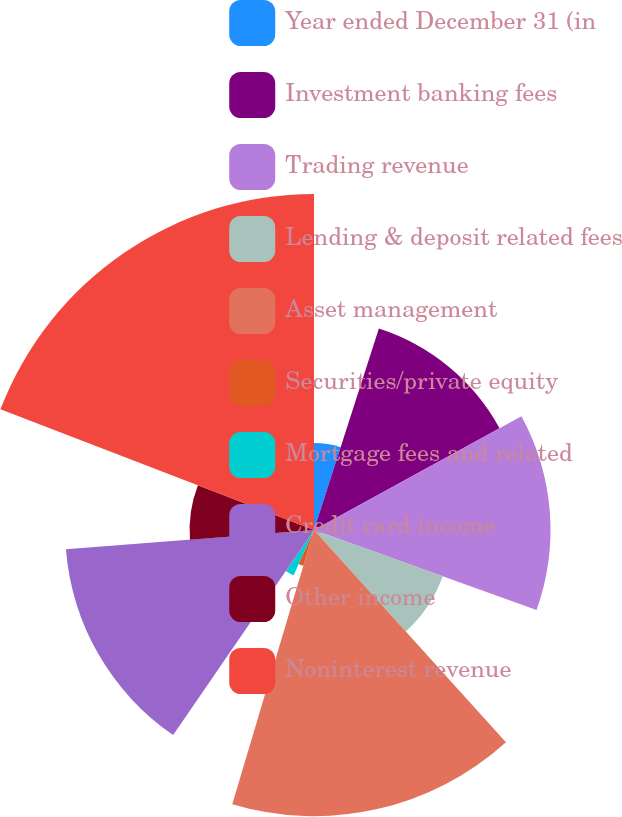Convert chart. <chart><loc_0><loc_0><loc_500><loc_500><pie_chart><fcel>Year ended December 31 (in<fcel>Investment banking fees<fcel>Trading revenue<fcel>Lending & deposit related fees<fcel>Asset management<fcel>Securities/private equity<fcel>Mortgage fees and related<fcel>Credit card income<fcel>Other income<fcel>Noninterest revenue<nl><fcel>4.96%<fcel>12.06%<fcel>13.48%<fcel>7.8%<fcel>16.31%<fcel>2.13%<fcel>2.84%<fcel>14.18%<fcel>7.09%<fcel>19.15%<nl></chart> 